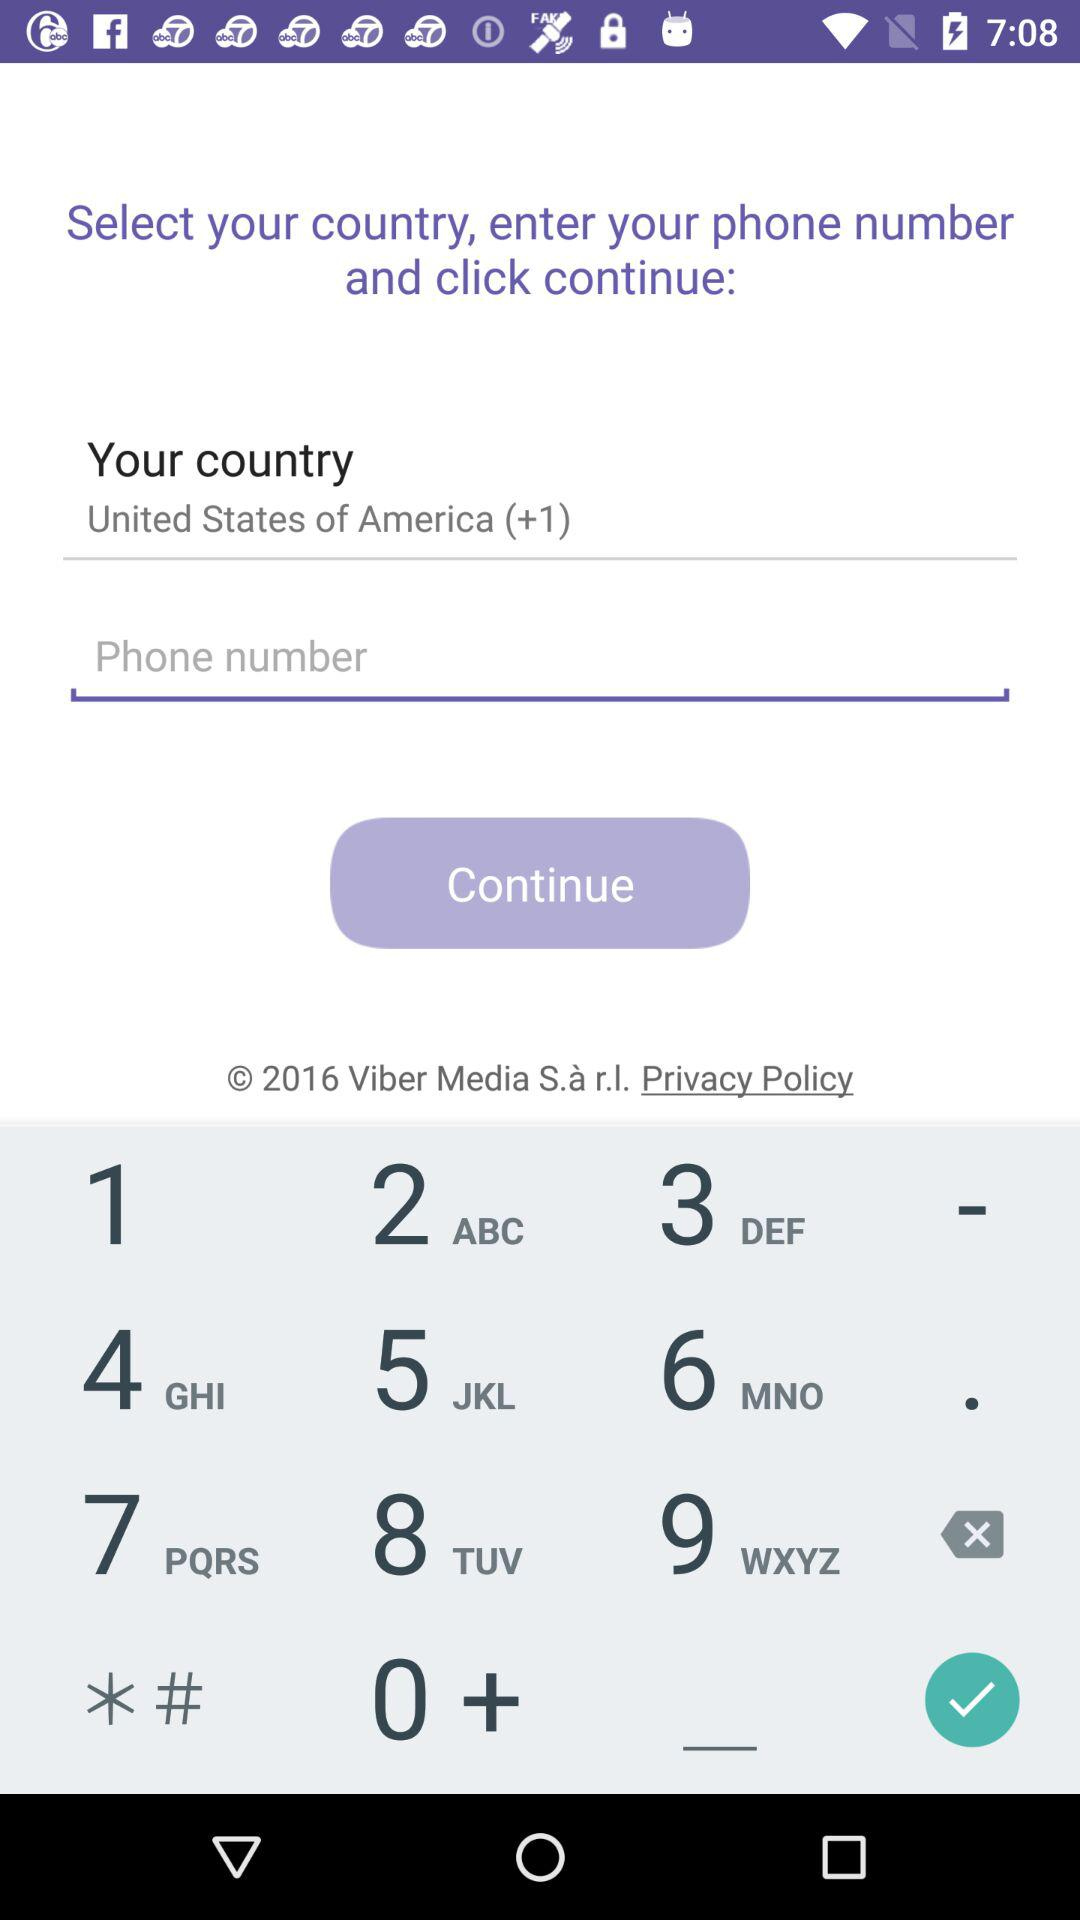What is the year of copyright for the application? The year of the copyright is 2016. 